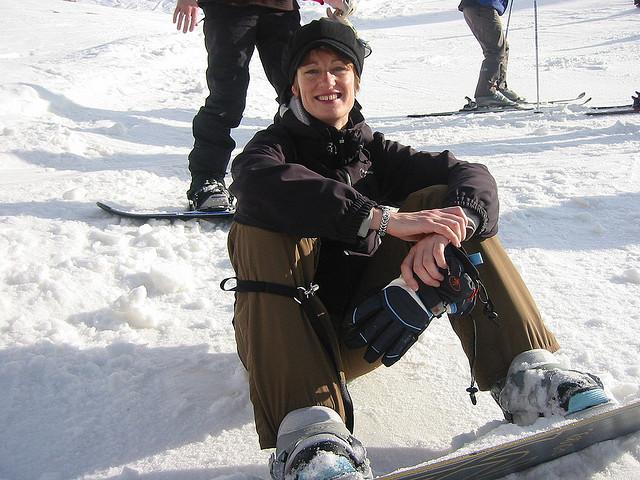Is the person wearing a hat?
Quick response, please. Yes. Does the snowboarder appear to be injured?
Be succinct. No. Is the snowboarder smiling?
Keep it brief. Yes. 